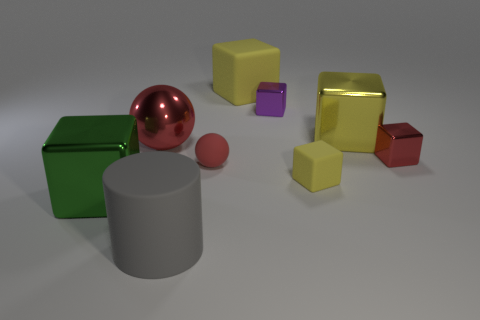Subtract all red metal cubes. How many cubes are left? 5 Subtract all green cubes. How many cubes are left? 5 Subtract 1 cylinders. How many cylinders are left? 0 Subtract all spheres. How many objects are left? 7 Subtract all purple spheres. Subtract all purple blocks. How many spheres are left? 2 Subtract all gray balls. How many yellow blocks are left? 3 Subtract all gray objects. Subtract all tiny red matte balls. How many objects are left? 7 Add 5 yellow metal things. How many yellow metal things are left? 6 Add 8 large yellow matte cylinders. How many large yellow matte cylinders exist? 8 Subtract 0 blue cylinders. How many objects are left? 9 